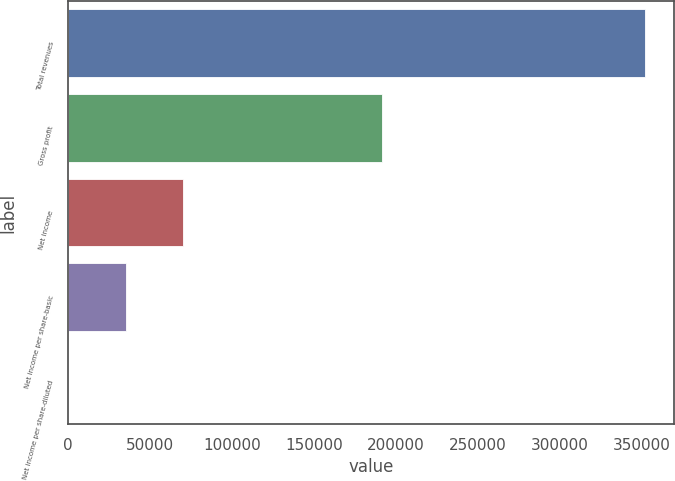Convert chart. <chart><loc_0><loc_0><loc_500><loc_500><bar_chart><fcel>Total revenues<fcel>Gross profit<fcel>Net income<fcel>Net income per share-basic<fcel>Net income per share-diluted<nl><fcel>351811<fcel>191660<fcel>70362.3<fcel>35181.2<fcel>0.16<nl></chart> 